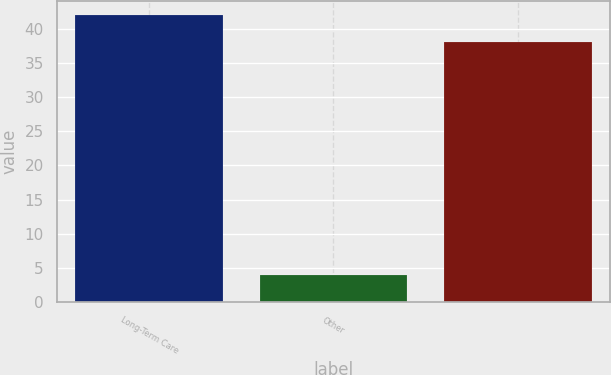<chart> <loc_0><loc_0><loc_500><loc_500><bar_chart><fcel>Long-Term Care<fcel>Other<fcel>Unnamed: 2<nl><fcel>42<fcel>4<fcel>38<nl></chart> 